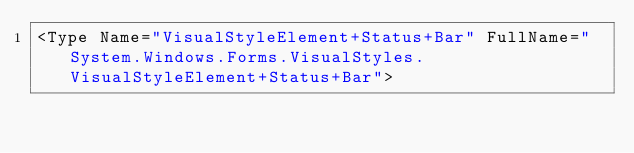<code> <loc_0><loc_0><loc_500><loc_500><_XML_><Type Name="VisualStyleElement+Status+Bar" FullName="System.Windows.Forms.VisualStyles.VisualStyleElement+Status+Bar"></code> 